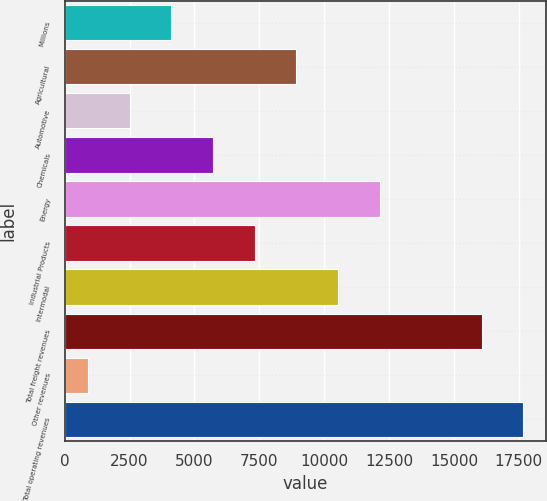Convert chart. <chart><loc_0><loc_0><loc_500><loc_500><bar_chart><fcel>Millions<fcel>Agricultural<fcel>Automotive<fcel>Chemicals<fcel>Energy<fcel>Industrial Products<fcel>Intermodal<fcel>Total freight revenues<fcel>Other revenues<fcel>Total operating revenues<nl><fcel>4109.8<fcel>8930.5<fcel>2502.9<fcel>5716.7<fcel>12144.3<fcel>7323.6<fcel>10537.4<fcel>16069<fcel>896<fcel>17675.9<nl></chart> 